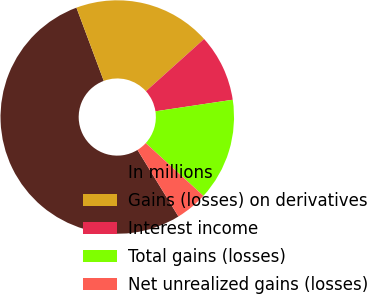<chart> <loc_0><loc_0><loc_500><loc_500><pie_chart><fcel>In millions<fcel>Gains (losses) on derivatives<fcel>Interest income<fcel>Total gains (losses)<fcel>Net unrealized gains (losses)<nl><fcel>53.09%<fcel>19.03%<fcel>9.29%<fcel>14.16%<fcel>4.43%<nl></chart> 